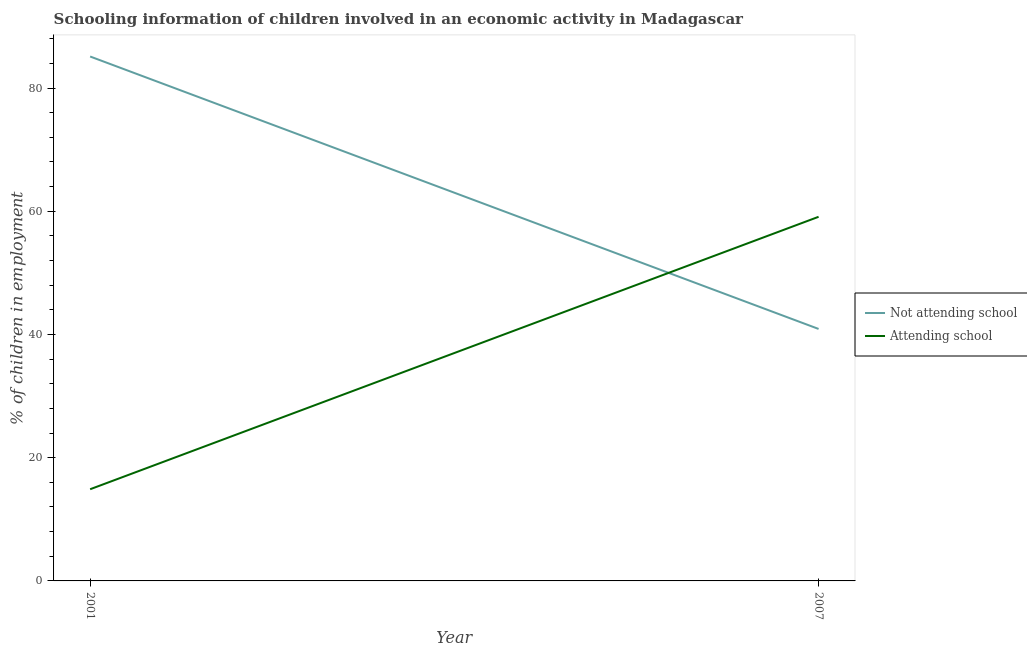Does the line corresponding to percentage of employed children who are not attending school intersect with the line corresponding to percentage of employed children who are attending school?
Your answer should be compact. Yes. Is the number of lines equal to the number of legend labels?
Provide a short and direct response. Yes. What is the percentage of employed children who are not attending school in 2007?
Provide a short and direct response. 40.9. Across all years, what is the maximum percentage of employed children who are attending school?
Provide a short and direct response. 59.1. Across all years, what is the minimum percentage of employed children who are attending school?
Make the answer very short. 14.88. In which year was the percentage of employed children who are not attending school minimum?
Give a very brief answer. 2007. What is the total percentage of employed children who are attending school in the graph?
Keep it short and to the point. 73.98. What is the difference between the percentage of employed children who are not attending school in 2001 and that in 2007?
Make the answer very short. 44.22. What is the difference between the percentage of employed children who are not attending school in 2001 and the percentage of employed children who are attending school in 2007?
Offer a very short reply. 26.02. What is the average percentage of employed children who are not attending school per year?
Make the answer very short. 63.01. In the year 2001, what is the difference between the percentage of employed children who are not attending school and percentage of employed children who are attending school?
Offer a terse response. 70.24. In how many years, is the percentage of employed children who are not attending school greater than 56 %?
Keep it short and to the point. 1. What is the ratio of the percentage of employed children who are not attending school in 2001 to that in 2007?
Provide a succinct answer. 2.08. Is the percentage of employed children who are attending school in 2001 less than that in 2007?
Your answer should be compact. Yes. How many lines are there?
Ensure brevity in your answer.  2. How many years are there in the graph?
Offer a very short reply. 2. Does the graph contain any zero values?
Keep it short and to the point. No. Does the graph contain grids?
Your answer should be very brief. No. How many legend labels are there?
Provide a succinct answer. 2. How are the legend labels stacked?
Give a very brief answer. Vertical. What is the title of the graph?
Provide a succinct answer. Schooling information of children involved in an economic activity in Madagascar. What is the label or title of the X-axis?
Provide a succinct answer. Year. What is the label or title of the Y-axis?
Give a very brief answer. % of children in employment. What is the % of children in employment of Not attending school in 2001?
Keep it short and to the point. 85.12. What is the % of children in employment of Attending school in 2001?
Offer a terse response. 14.88. What is the % of children in employment in Not attending school in 2007?
Ensure brevity in your answer.  40.9. What is the % of children in employment of Attending school in 2007?
Ensure brevity in your answer.  59.1. Across all years, what is the maximum % of children in employment of Not attending school?
Make the answer very short. 85.12. Across all years, what is the maximum % of children in employment of Attending school?
Provide a short and direct response. 59.1. Across all years, what is the minimum % of children in employment of Not attending school?
Ensure brevity in your answer.  40.9. Across all years, what is the minimum % of children in employment of Attending school?
Your response must be concise. 14.88. What is the total % of children in employment in Not attending school in the graph?
Provide a succinct answer. 126.02. What is the total % of children in employment of Attending school in the graph?
Ensure brevity in your answer.  73.98. What is the difference between the % of children in employment in Not attending school in 2001 and that in 2007?
Give a very brief answer. 44.22. What is the difference between the % of children in employment in Attending school in 2001 and that in 2007?
Offer a terse response. -44.22. What is the difference between the % of children in employment of Not attending school in 2001 and the % of children in employment of Attending school in 2007?
Keep it short and to the point. 26.02. What is the average % of children in employment of Not attending school per year?
Make the answer very short. 63.01. What is the average % of children in employment in Attending school per year?
Provide a short and direct response. 36.99. In the year 2001, what is the difference between the % of children in employment of Not attending school and % of children in employment of Attending school?
Provide a short and direct response. 70.24. In the year 2007, what is the difference between the % of children in employment of Not attending school and % of children in employment of Attending school?
Give a very brief answer. -18.2. What is the ratio of the % of children in employment of Not attending school in 2001 to that in 2007?
Offer a very short reply. 2.08. What is the ratio of the % of children in employment in Attending school in 2001 to that in 2007?
Keep it short and to the point. 0.25. What is the difference between the highest and the second highest % of children in employment in Not attending school?
Provide a short and direct response. 44.22. What is the difference between the highest and the second highest % of children in employment in Attending school?
Offer a very short reply. 44.22. What is the difference between the highest and the lowest % of children in employment in Not attending school?
Offer a very short reply. 44.22. What is the difference between the highest and the lowest % of children in employment in Attending school?
Make the answer very short. 44.22. 